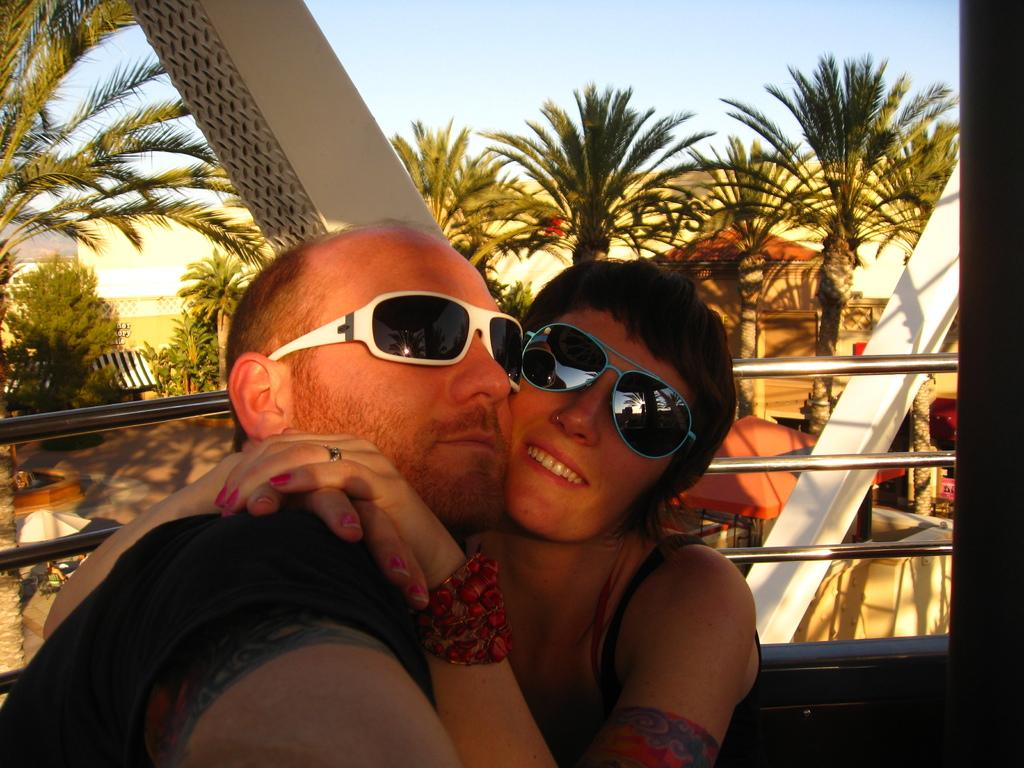How many people are present in the image? There is a man and a woman in the image. Where are the man and woman located in the image? The man and woman are at the bottom of the image. What is behind the man and woman? There is a railing behind the man and woman. What can be seen in the background of the image? There are no cakes present in the image. What type of paint is being used by the man and woman in the image? There is no paint or painting activity depicted in the image. What type of land can be seen in the image? There is no specific type of land mentioned or depicted in the image. How many layers of cake can be seen in the image? There is no cake present in the image. 